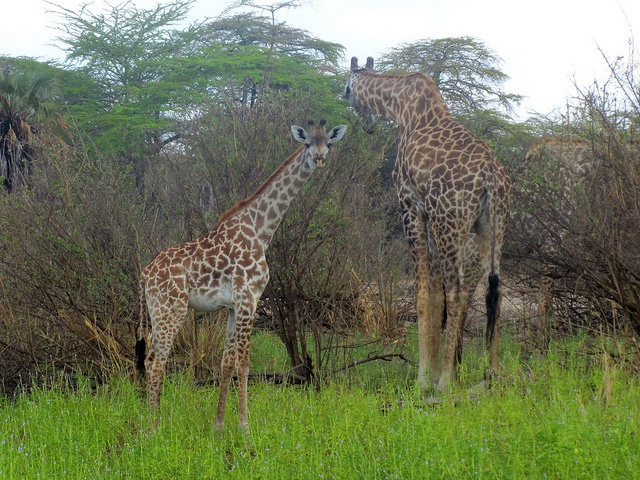Describe the objects in this image and their specific colors. I can see giraffe in white, gray, and darkgray tones and giraffe in white, gray, and darkgray tones in this image. 